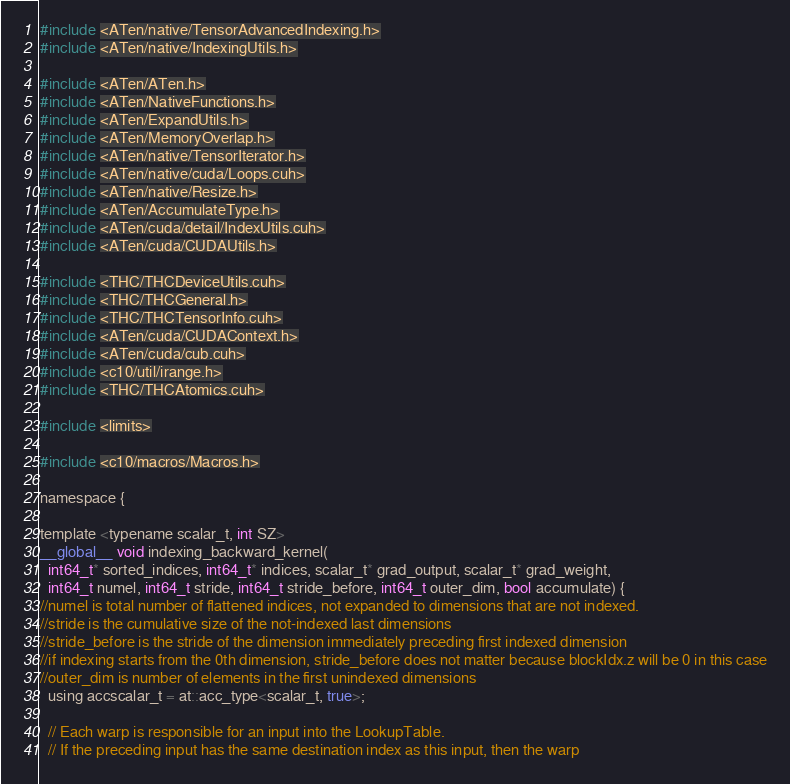Convert code to text. <code><loc_0><loc_0><loc_500><loc_500><_Cuda_>#include <ATen/native/TensorAdvancedIndexing.h>
#include <ATen/native/IndexingUtils.h>

#include <ATen/ATen.h>
#include <ATen/NativeFunctions.h>
#include <ATen/ExpandUtils.h>
#include <ATen/MemoryOverlap.h>
#include <ATen/native/TensorIterator.h>
#include <ATen/native/cuda/Loops.cuh>
#include <ATen/native/Resize.h>
#include <ATen/AccumulateType.h>
#include <ATen/cuda/detail/IndexUtils.cuh>
#include <ATen/cuda/CUDAUtils.h>

#include <THC/THCDeviceUtils.cuh>
#include <THC/THCGeneral.h>
#include <THC/THCTensorInfo.cuh>
#include <ATen/cuda/CUDAContext.h>
#include <ATen/cuda/cub.cuh>
#include <c10/util/irange.h>
#include <THC/THCAtomics.cuh>

#include <limits>

#include <c10/macros/Macros.h>

namespace {

template <typename scalar_t, int SZ>
__global__ void indexing_backward_kernel(
  int64_t* sorted_indices, int64_t* indices, scalar_t* grad_output, scalar_t* grad_weight,
  int64_t numel, int64_t stride, int64_t stride_before, int64_t outer_dim, bool accumulate) {
//numel is total number of flattened indices, not expanded to dimensions that are not indexed.
//stride is the cumulative size of the not-indexed last dimensions
//stride_before is the stride of the dimension immediately preceding first indexed dimension
//if indexing starts from the 0th dimension, stride_before does not matter because blockIdx.z will be 0 in this case
//outer_dim is number of elements in the first unindexed dimensions
  using accscalar_t = at::acc_type<scalar_t, true>;

  // Each warp is responsible for an input into the LookupTable.
  // If the preceding input has the same destination index as this input, then the warp</code> 